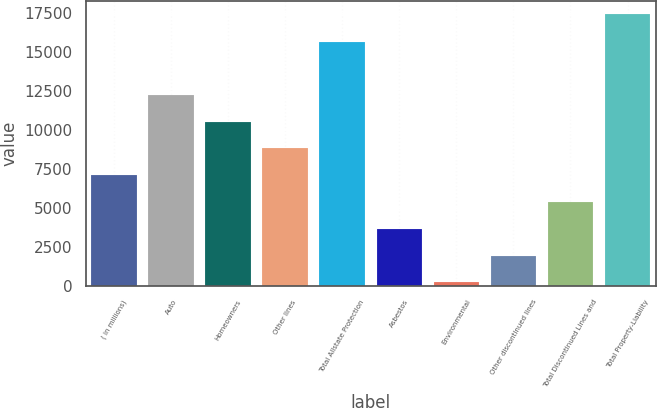Convert chart. <chart><loc_0><loc_0><loc_500><loc_500><bar_chart><fcel>( in millions)<fcel>Auto<fcel>Homeowners<fcel>Other lines<fcel>Total Allstate Protection<fcel>Asbestos<fcel>Environmental<fcel>Other discontinued lines<fcel>Total Discontinued Lines and<fcel>Total Property-Liability<nl><fcel>7079<fcel>12237.5<fcel>10518<fcel>8798.5<fcel>15617<fcel>3640<fcel>201<fcel>1920.5<fcel>5359.5<fcel>17396<nl></chart> 